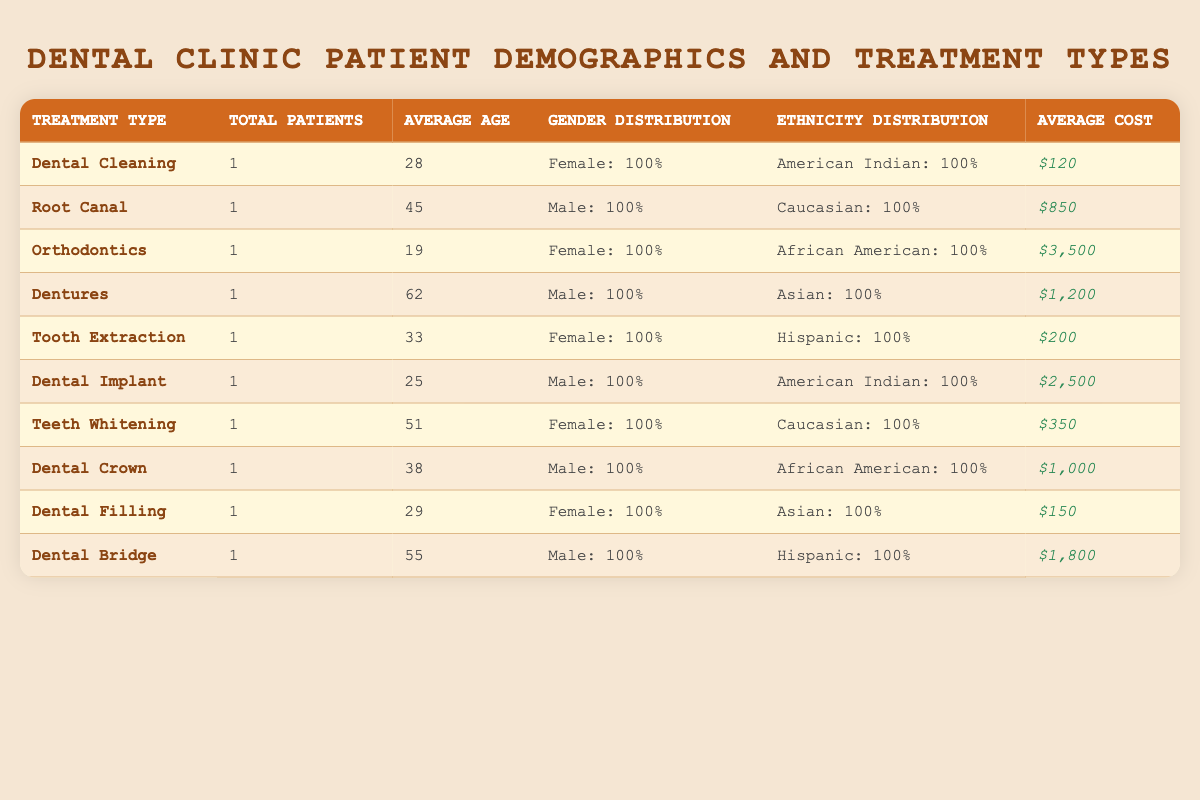What is the treatment type with the highest average cost? The highest average cost in the table is $3,500, which corresponds to the treatment type "Orthodontics." This is determined by comparing all the average costs listed for each treatment type.
Answer: Orthodontics How many female patients received treatment for Dental Cleaning? There is one entry for "Dental Cleaning," which shows that the patient is female. Therefore, the count of female patients for this treatment type is 1.
Answer: 1 What is the average age of patients who underwent Tooth Extraction and Dental Crown? The average age for Tooth Extraction is 33 and for Dental Crown is 38. To find the combined average, add their ages (33 + 38 = 71) and divide by 2 (71 / 2 = 35.5).
Answer: 35.5 Is there any treatment type that has only male patients? Yes, the treatment types "Root Canal," "Dentures," and "Dental Bridge" each have only male patients according to the gender distribution column in the table.
Answer: Yes What percentage of patients receiving Dental Implants are American Indian? There is 1 patient for the treatment type "Dental Implant," who is American Indian. Therefore, when calculating the percentage, it's (1 / 1) * 100% which equals 100%.
Answer: 100% What is the total cost of all treatments performed by Dr. Sarah Johnson? Dr. Sarah Johnson has three entries: "Dental Cleaning" costing $120, "Dentures" costing $1,200, and "Dental Bridge" costing $1,800. To find the total cost, sum these costs (120 + 1200 + 1800 = 3120).
Answer: $3,120 Which treatment type has the lowest average cost? The treatment type "Dental Filling" has the lowest average cost listed, which is $150. This is identified by comparing the cost of each treatment type in the average cost column.
Answer: Dental Filling How many treatment types have only one patient receiving them? Each treatment type in the table has only one corresponding patient. Counting these gives a total of 10 treatment types, confirming that all have only one patient.
Answer: 10 What is the average age of patients who had treatments other than Dentures? Excluding Dentures, the ages of the other patients are 28, 45, 19, 33, 25, 51, 38, 29, and 55. Adding these gives a total of 304, and since there are 9 patients, the average age is (304 / 9) = 33.78.
Answer: 33.78 